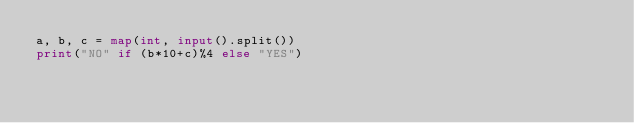<code> <loc_0><loc_0><loc_500><loc_500><_Python_>a, b, c = map(int, input().split())
print("NO" if (b*10+c)%4 else "YES")</code> 